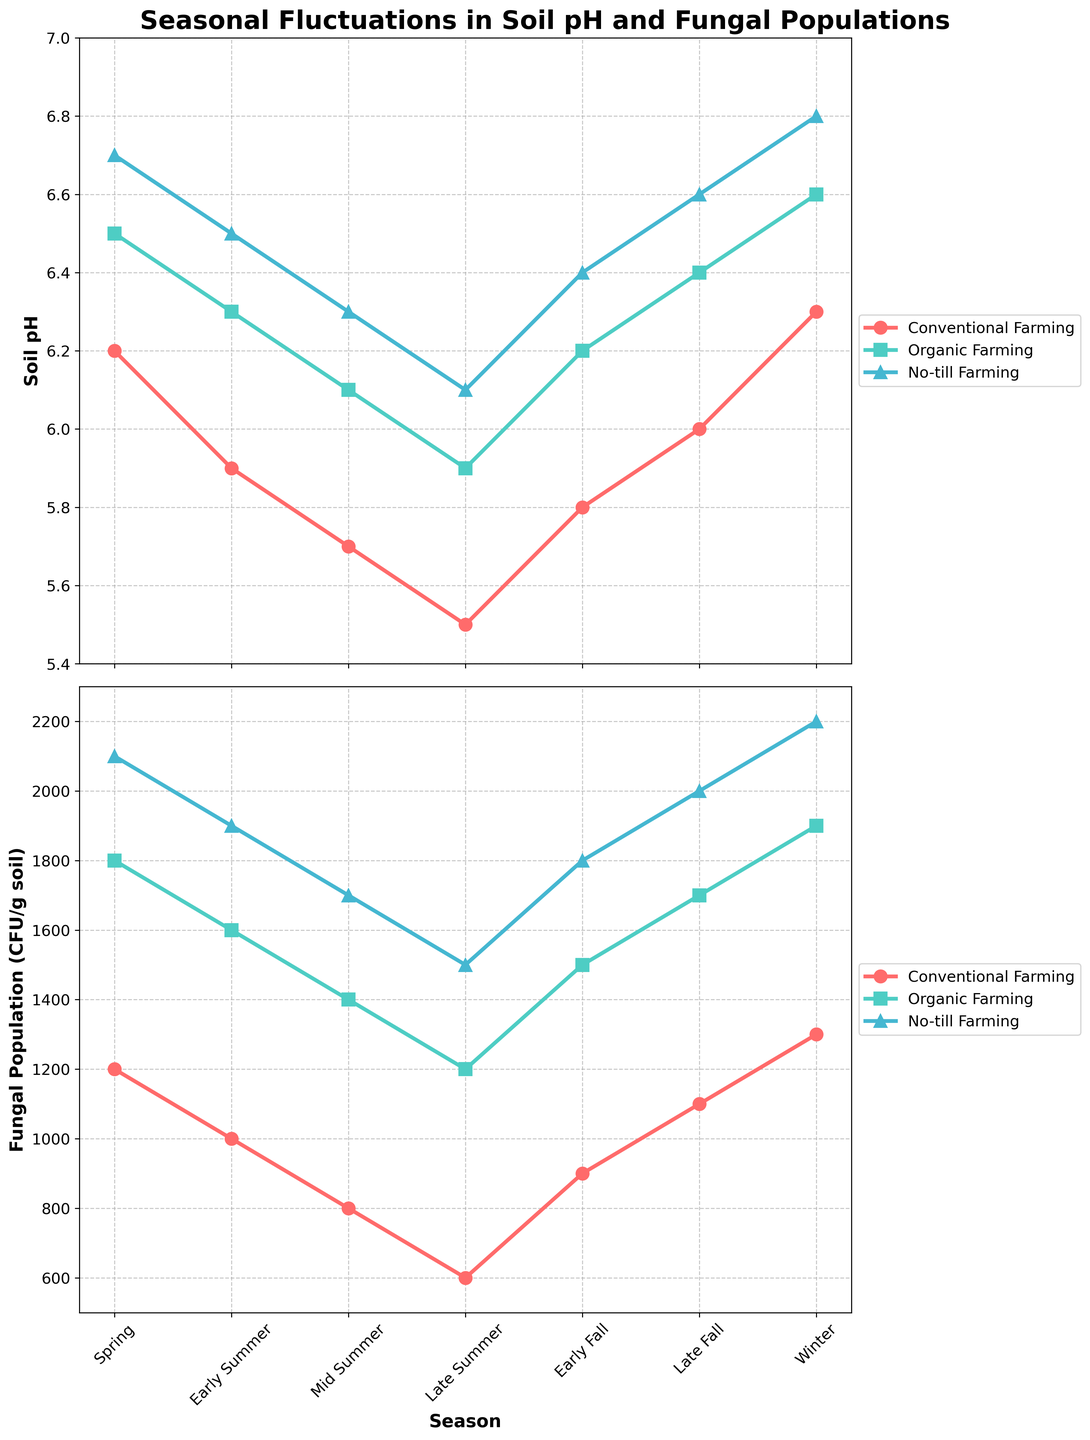What is the difference in soil pH between Early Summer and Winter for Conventional Farming? In Early Summer, the soil pH for Conventional Farming is 5.9, whereas, in Winter, it is 6.3. The difference is calculated by subtracting the Early Summer pH from the Winter pH, i.e., 6.3 - 5.9.
Answer: 0.4 Which farming system shows the highest fungal population in Mid Summer? By examining the fungal population data for Mid Summer, we see: Conventional Farming (800), Organic Farming (1400), and No-till Farming (1700). The highest population is in No-till Farming.
Answer: No-till Farming During which season does Organic Farming have the lowest soil pH? By looking at the data for Organic Farming soil pH across seasons, we see it reaches its lowest value in Late Summer (5.9).
Answer: Late Summer Compare the fungal populations for No-till and Organic Farming in Early Fall. Which has a greater number, and by how much? In Early Fall, No-till Farming has a fungal population of 1800, while Organic Farming has 1500. The difference is calculated by subtracting the Organic Farming population from No-till's, i.e., 1800 - 1500.
Answer: No-till Farming, 300 What is the average soil pH for Conventional Farming over the entire year? To find the average soil pH for Conventional Farming, sum the values for each season (6.2, 5.9, 5.7, 5.5, 5.8, 6.0, 6.3) and then divide by the number of seasons (7). The sum is 41.4, and the average is 41.4 / 7.
Answer: 5.9 How does the fungal population in Late Fall compare between No-till and Conventional Farming? In Late Fall, the fungal population for No-till Farming is 2000, and for Conventional Farming, it is 1100. No-till Farming has more fungal population than Conventional Farming by 2000 - 1100.
Answer: No-till Farming, 900 more In which season does the fungal population in Organic Farming see the steepest decline? The fungal populations for Organic Farming drop most steeply between Early Summer (1600) and Mid Summer (1400), a difference of 200.
Answer: Early Summer to Mid Summer 